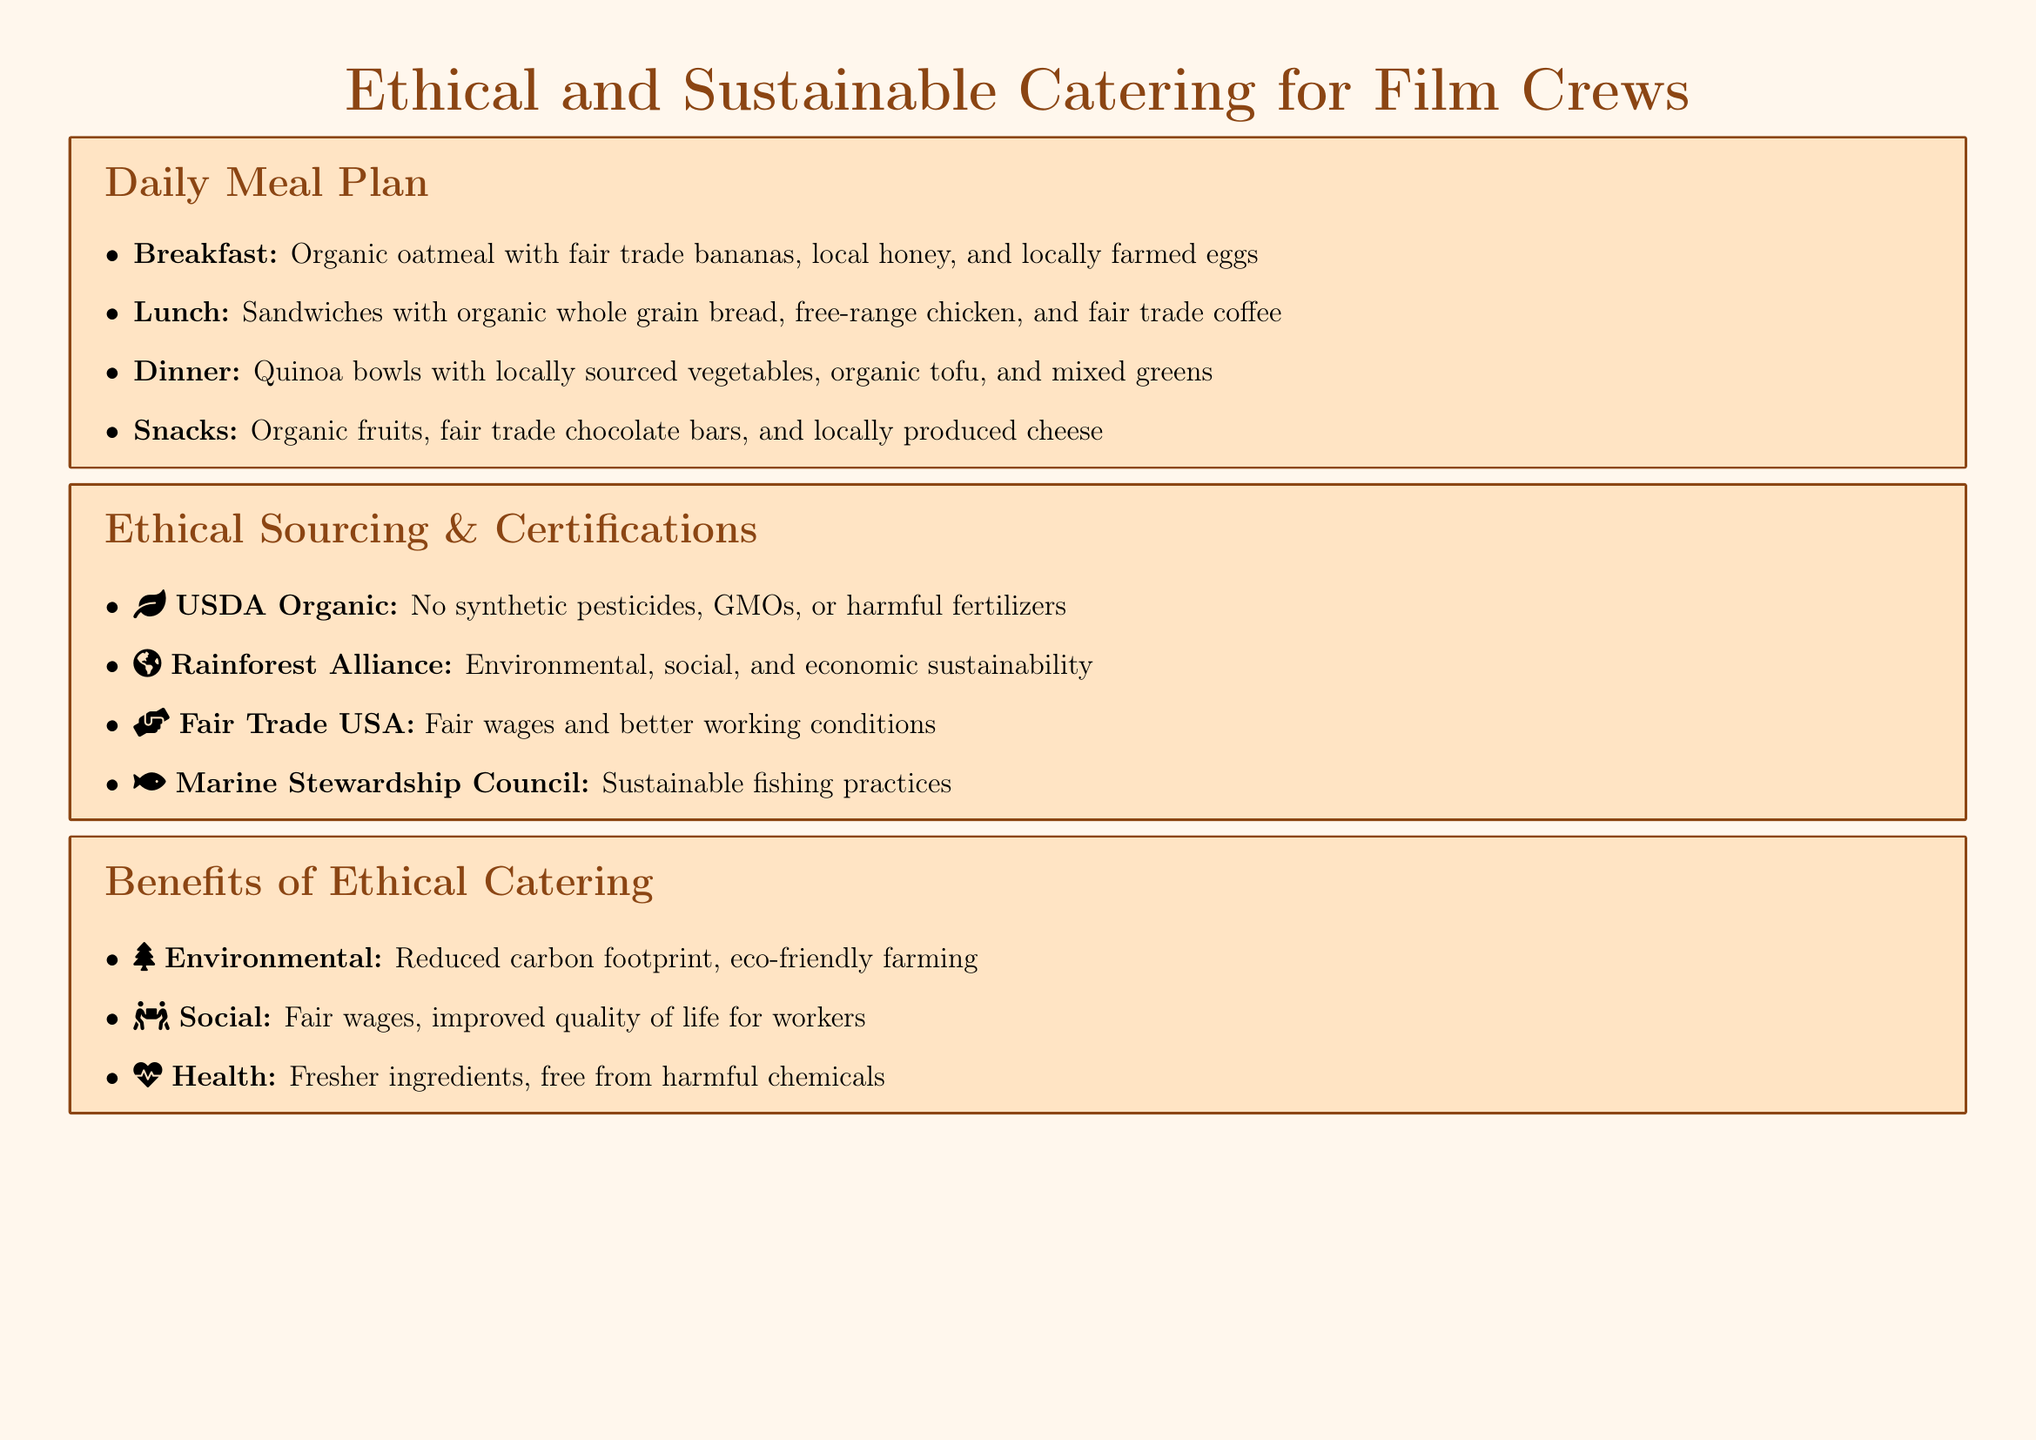What is included in the breakfast item? Breakfast item includes organic oatmeal with fair trade bananas, local honey, and locally farmed eggs.
Answer: Organic oatmeal, fair trade bananas, local honey, locally farmed eggs What type of bread is used for the lunch sandwiches? The document specifies that organic whole grain bread is used for the lunch sandwiches.
Answer: Organic whole grain bread What certification guarantees no synthetic pesticides? The document states that the USDA Organic certification ensures no synthetic pesticides, GMOs, or harmful fertilizers.
Answer: USDA Organic What is one of the benefits of ethical catering mentioned? The document lists benefits including environmental, social, and health factors related to ethical catering.
Answer: Reduced carbon footprint How many real-world examples of ethical catering are provided? There are three real-world examples mentioned in the document: Sweetgreen, Farm-to-Table, and The Bread & Butter Project.
Answer: Three Which organization is responsible for fair trade certification? Fair Trade USA is the organization mentioned in the document responsible for fair trade certification.
Answer: Fair Trade USA What type of sourcing does Sweetgreen utilize? The document notes that Sweetgreen utilizes local and organic ingredients with transparent sourcing.
Answer: Local and organic ingredients Which meal includes locally sourced vegetables? The dinner item is specified to include locally sourced vegetables.
Answer: Dinner 